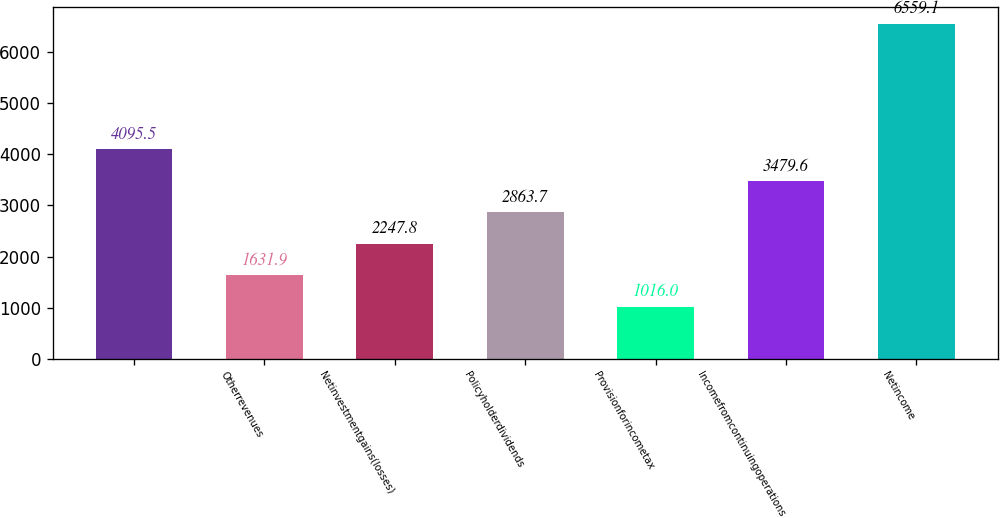<chart> <loc_0><loc_0><loc_500><loc_500><bar_chart><ecel><fcel>Otherrevenues<fcel>Netinvestmentgains(losses)<fcel>Policyholderdividends<fcel>Provisionforincometax<fcel>Incomefromcontinuingoperations<fcel>Netincome<nl><fcel>4095.5<fcel>1631.9<fcel>2247.8<fcel>2863.7<fcel>1016<fcel>3479.6<fcel>6559.1<nl></chart> 